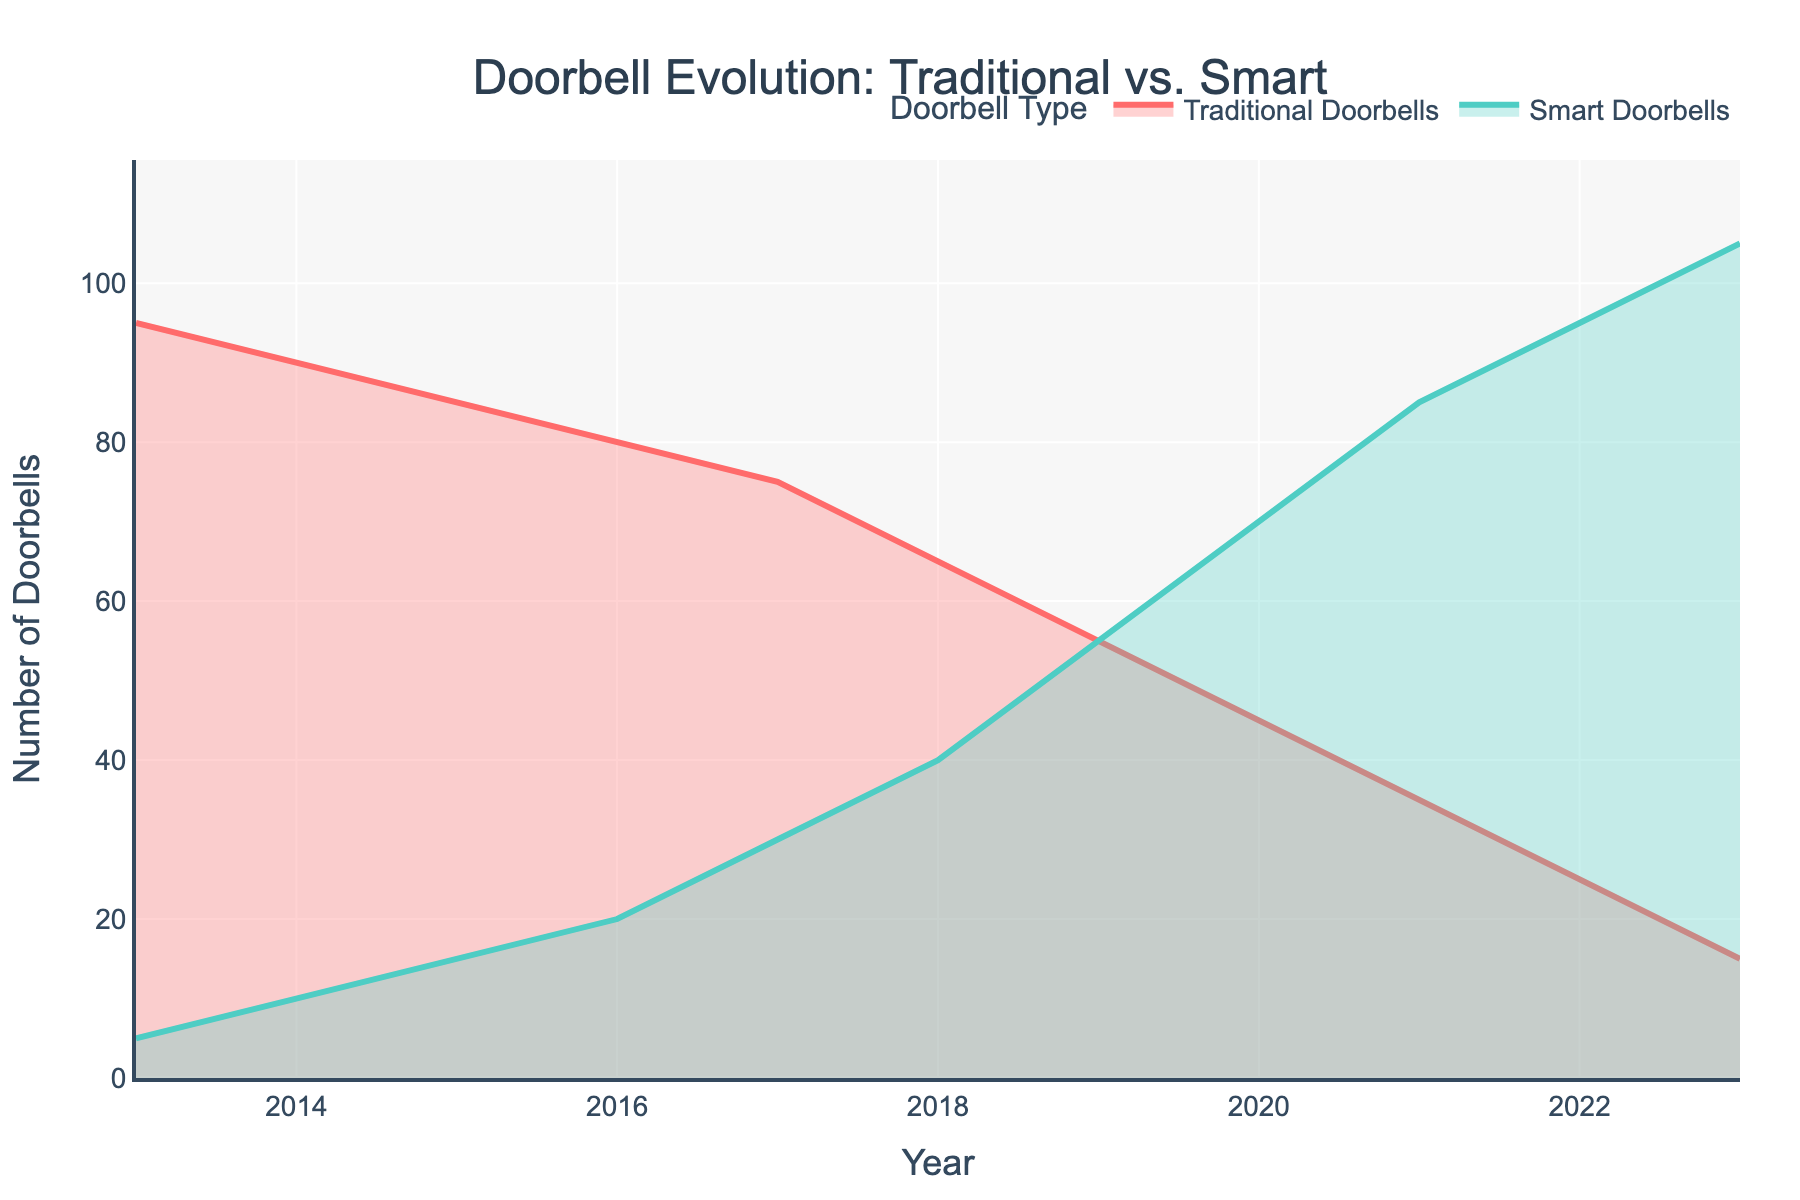What is the title of the chart? The title is usually found at the top of the chart and gives a summary of what the data represents. In this case, the title is "Doorbell Evolution: Traditional vs. Smart".
Answer: Doorbell Evolution: Traditional vs. Smart Which year had the highest number of traditional doorbells? By looking at the line representing Traditional Doorbells, observe where it starts and find the highest y-value. This corresponds to the year 2013.
Answer: 2013 How many smart doorbells were there in the year 2020? Locate the point on the Smart Doorbells line that corresponds to the year 2020 and read the y-axis value.
Answer: 70 By how much did the number of traditional doorbells decrease from 2013 to 2023? Identify the y-values for the year 2013 and 2023 on the Traditional Doorbells line and calculate the difference: 95 - 15.
Answer: 80 Which year did smart doorbells surpass traditional doorbells in number? Trace both lines and see where the Smart Doorbells line crosses above the Traditional Doorbells line. This crossover happens in 2019.
Answer: 2019 What is the overall trend for the number of traditional doorbells over the decade? The Traditional Doorbells line shows a downward trend from left (2013) to right (2023).
Answer: Decreasing How did the number of smart doorbells change from 2013 to 2019? Find the y-values for Smart Doorbells in 2013 and 2019, then calculate the increase: 55 - 5.
Answer: Increased by 50 What is the difference in the number of smart doorbells between 2016 and 2022? Identify the y-values for Smart Doorbells in 2016 and 2022, then calculate the difference: 95 - 20.
Answer: 75 What is the total number of doorbells (both traditional and smart) in 2023? Add the values of Traditional Doorbells and Smart Doorbells for the year 2023: 15 + 105.
Answer: 120 In which year was the gap between traditional and smart doorbells the largest? Determine the years by visually comparing the distance between the two lines, which is the largest around 2013.
Answer: 2013 